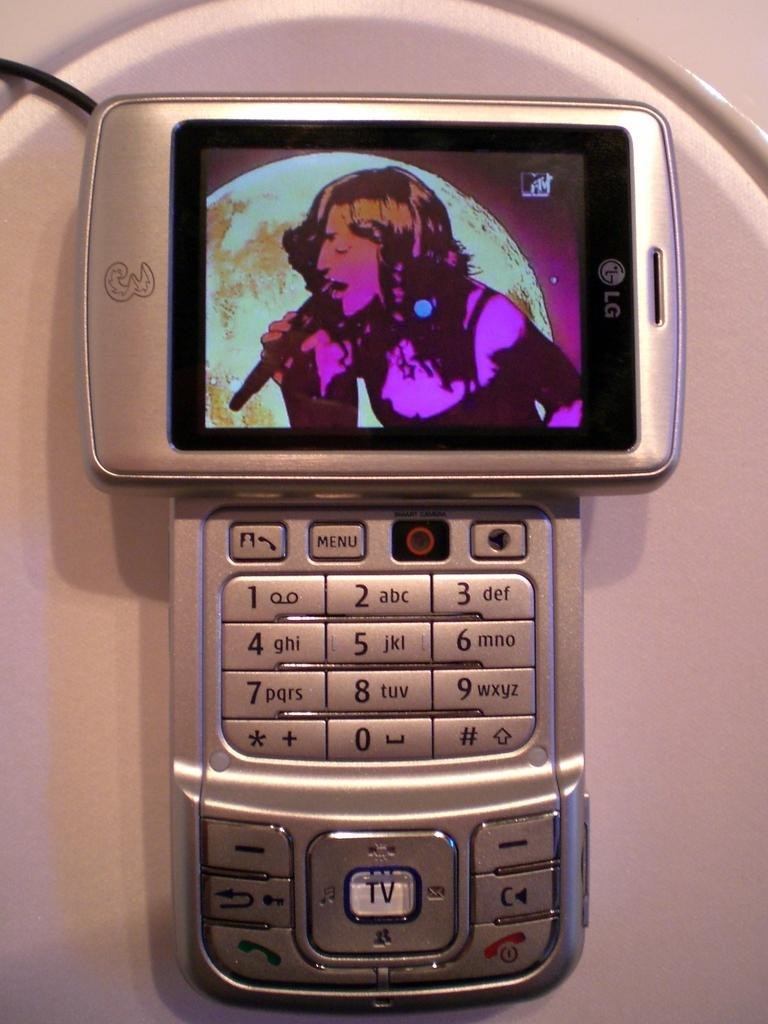<image>
Create a compact narrative representing the image presented. An LG phone has a big button that says TV on it. 